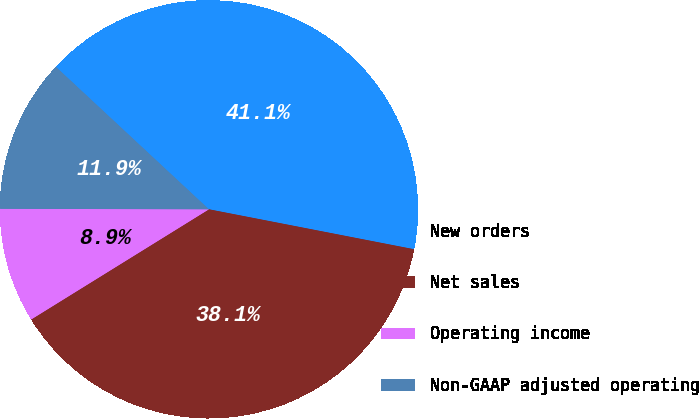Convert chart. <chart><loc_0><loc_0><loc_500><loc_500><pie_chart><fcel>New orders<fcel>Net sales<fcel>Operating income<fcel>Non-GAAP adjusted operating<nl><fcel>41.13%<fcel>38.11%<fcel>8.87%<fcel>11.89%<nl></chart> 